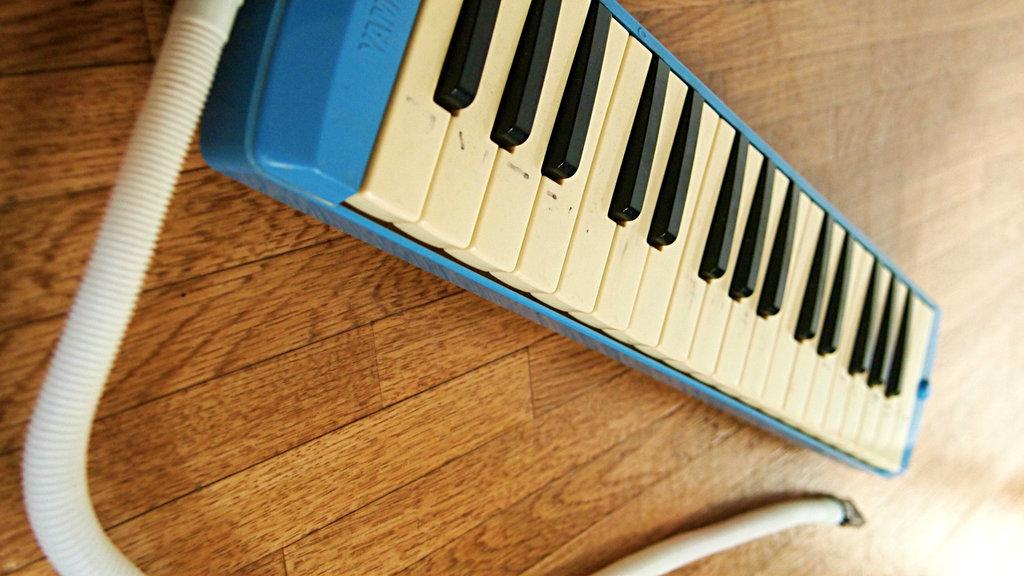What is the main object on the wooden plank in the image? There is a blue music keyboard on the wooden plank. What is the color of the music keyboard? The music keyboard is blue. Does the music keyboard have any keys? Yes, the music keyboard has a key. What is connected to the music keyboard in the image? There is a white wire connected to the music keyboard. What type of orange is being sliced in the image? There is no orange or any food preparation activity depicted in the image; it features a blue music keyboard on a wooden plank with a white wire connected to it. 